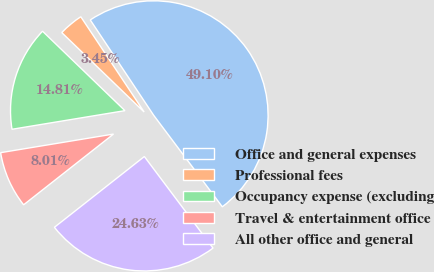Convert chart. <chart><loc_0><loc_0><loc_500><loc_500><pie_chart><fcel>Office and general expenses<fcel>Professional fees<fcel>Occupancy expense (excluding<fcel>Travel & entertainment office<fcel>All other office and general<nl><fcel>49.1%<fcel>3.45%<fcel>14.81%<fcel>8.01%<fcel>24.63%<nl></chart> 